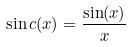Convert formula to latex. <formula><loc_0><loc_0><loc_500><loc_500>\sin c ( x ) = \frac { \sin ( x ) } { x }</formula> 